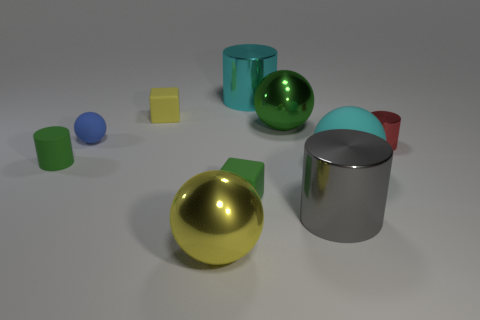There is a matte ball to the right of the metal sphere to the left of the large cylinder behind the small red metal object; how big is it?
Offer a terse response. Large. What shape is the large thing to the right of the shiny cylinder in front of the red cylinder?
Provide a short and direct response. Sphere. Is the color of the rubber block on the right side of the yellow shiny sphere the same as the rubber cylinder?
Provide a succinct answer. Yes. What color is the large ball that is to the left of the gray shiny object and behind the large yellow metallic object?
Provide a short and direct response. Green. Is there a yellow object made of the same material as the small blue thing?
Your answer should be compact. Yes. The yellow metallic sphere has what size?
Offer a very short reply. Large. What is the size of the matte sphere that is in front of the small cylinder to the right of the big yellow thing?
Your answer should be compact. Large. What material is the tiny green object that is the same shape as the red metal thing?
Give a very brief answer. Rubber. What number of large yellow objects are there?
Ensure brevity in your answer.  1. What color is the rubber sphere left of the matte ball that is in front of the small shiny object that is in front of the cyan cylinder?
Offer a very short reply. Blue. 